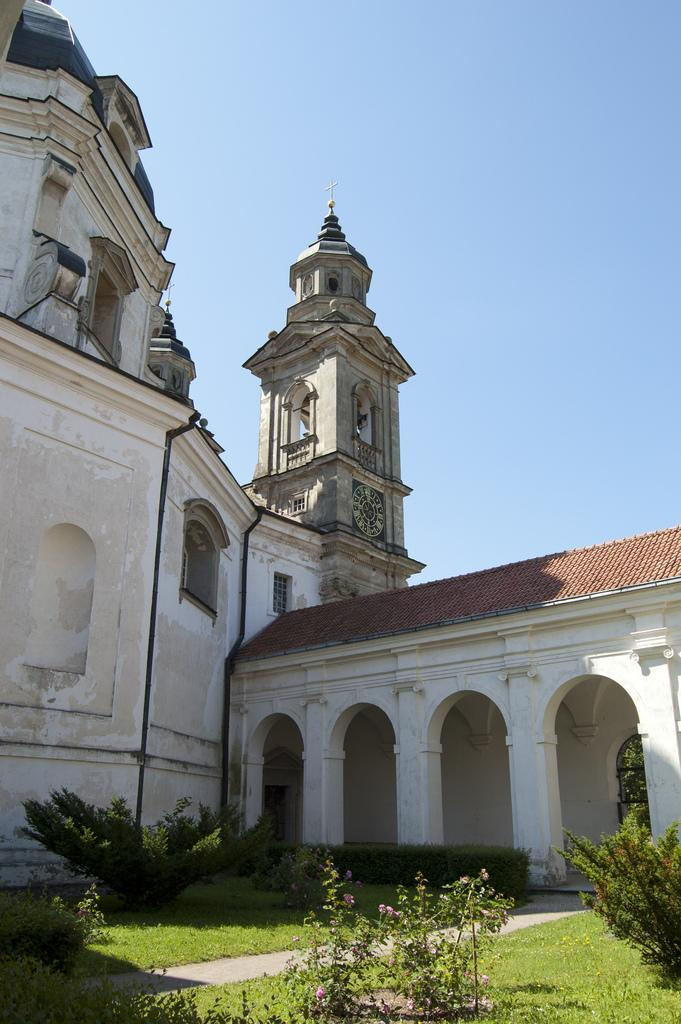What type of vegetation is at the bottom of the image? There is grass at the bottom of the image. What other types of vegetation can be seen in the image? There are plants and shrubs in the image. What can be seen in the background of the image? There is a building in the background of the image. What is visible at the top of the image? The sky is visible at the top of the image. What authority figure can be seen in the image? There is no authority figure present in the image. What letter is visible on the building in the image? There is no letter visible on the building in the image. 